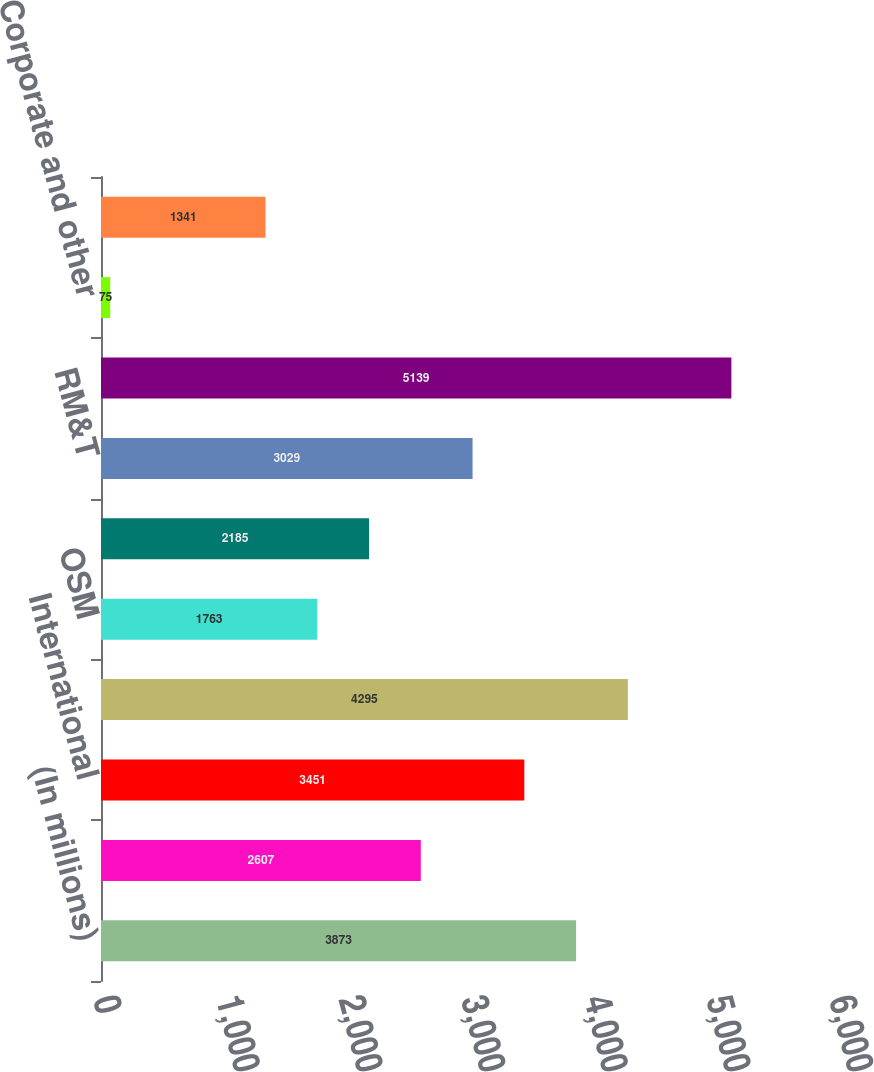<chart> <loc_0><loc_0><loc_500><loc_500><bar_chart><fcel>(In millions)<fcel>United States<fcel>International<fcel>E&P segment<fcel>OSM<fcel>IG<fcel>RM&T<fcel>Segment income<fcel>Corporate and other<fcel>Foreign currency effects on<nl><fcel>3873<fcel>2607<fcel>3451<fcel>4295<fcel>1763<fcel>2185<fcel>3029<fcel>5139<fcel>75<fcel>1341<nl></chart> 